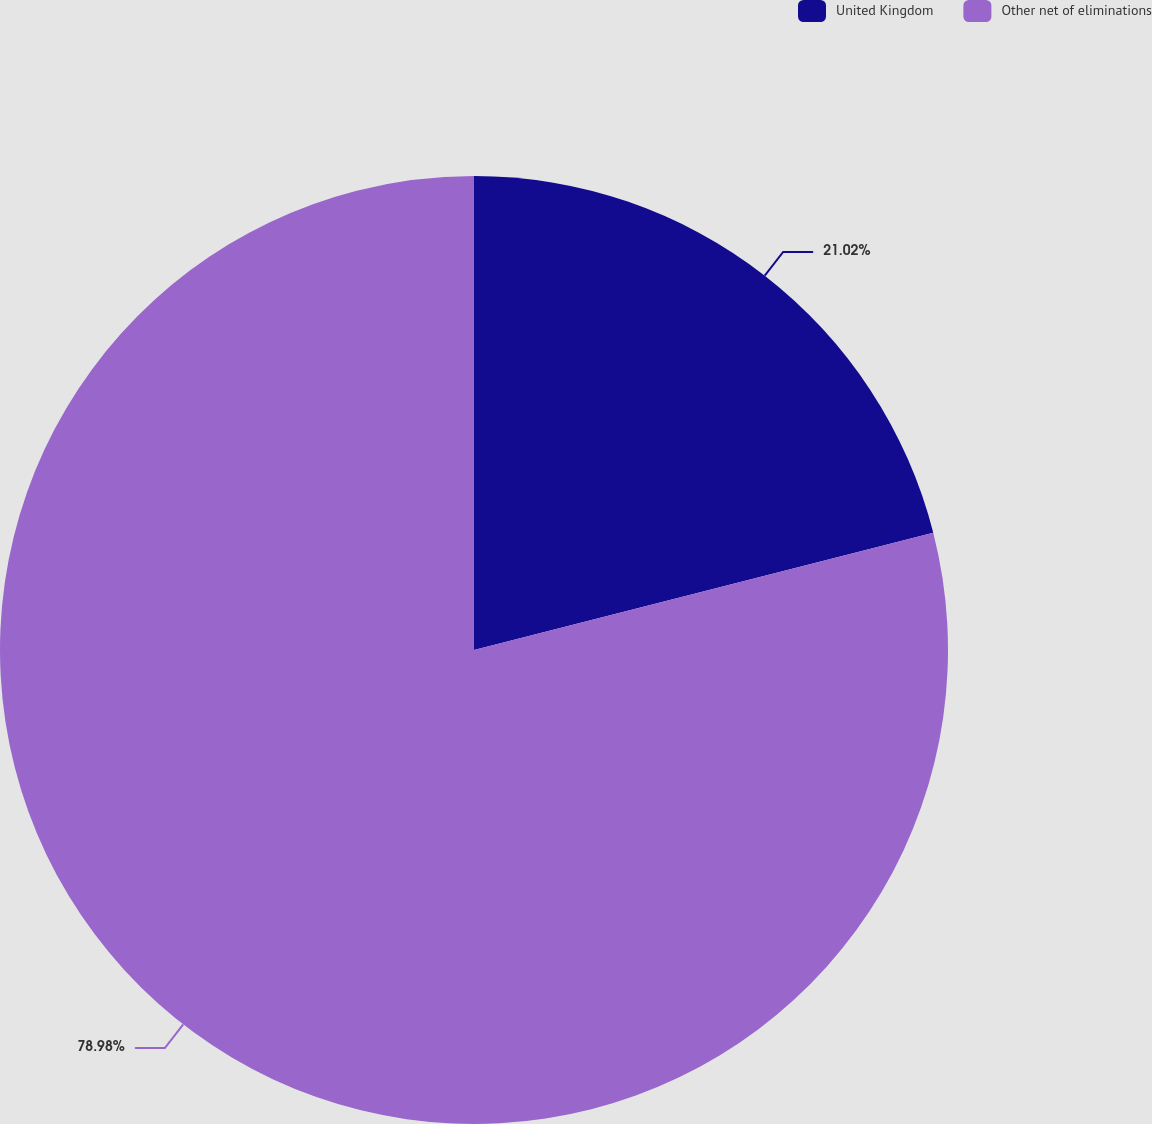Convert chart. <chart><loc_0><loc_0><loc_500><loc_500><pie_chart><fcel>United Kingdom<fcel>Other net of eliminations<nl><fcel>21.02%<fcel>78.98%<nl></chart> 